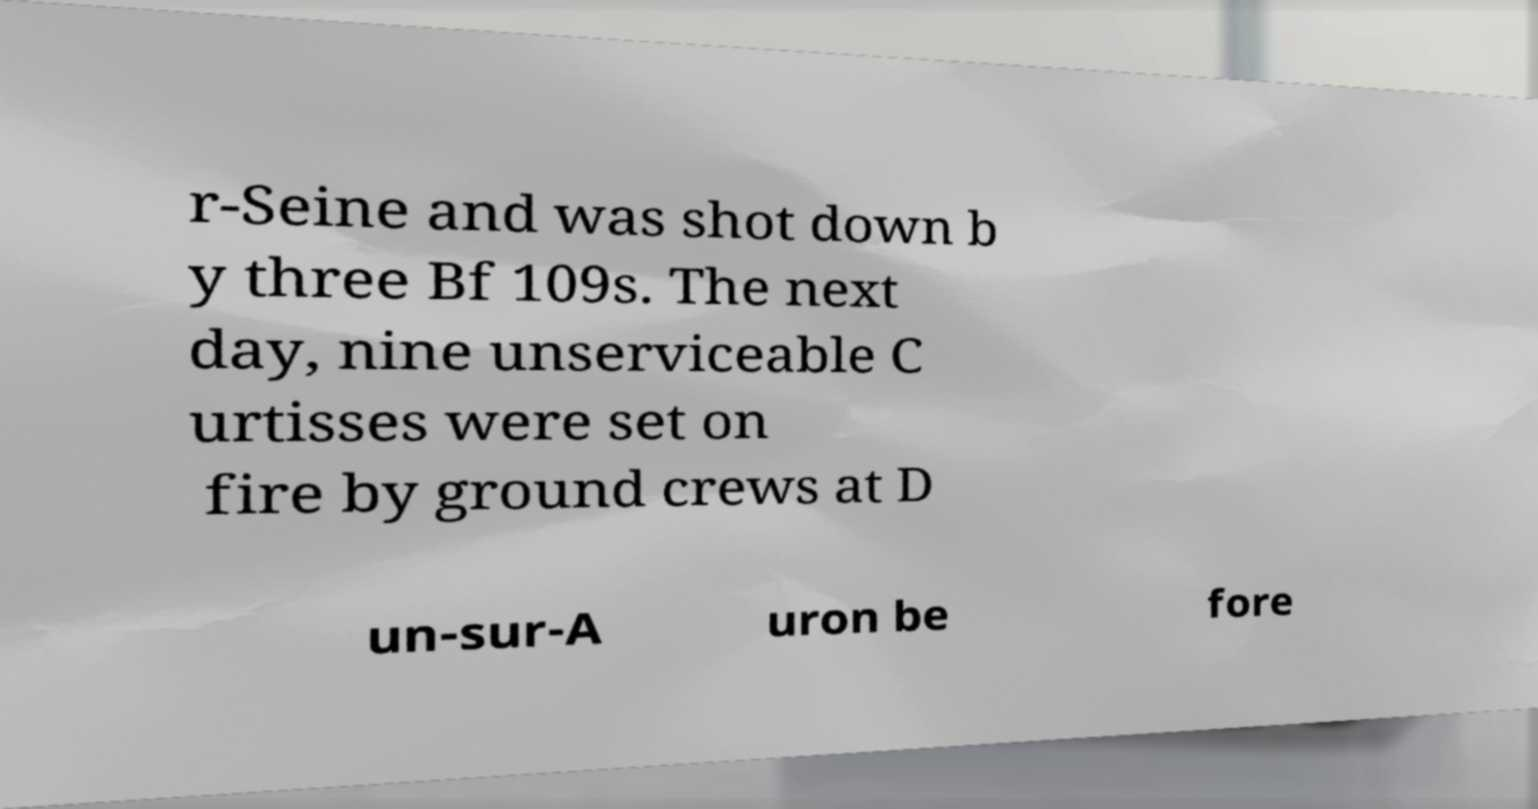What messages or text are displayed in this image? I need them in a readable, typed format. r-Seine and was shot down b y three Bf 109s. The next day, nine unserviceable C urtisses were set on fire by ground crews at D un-sur-A uron be fore 